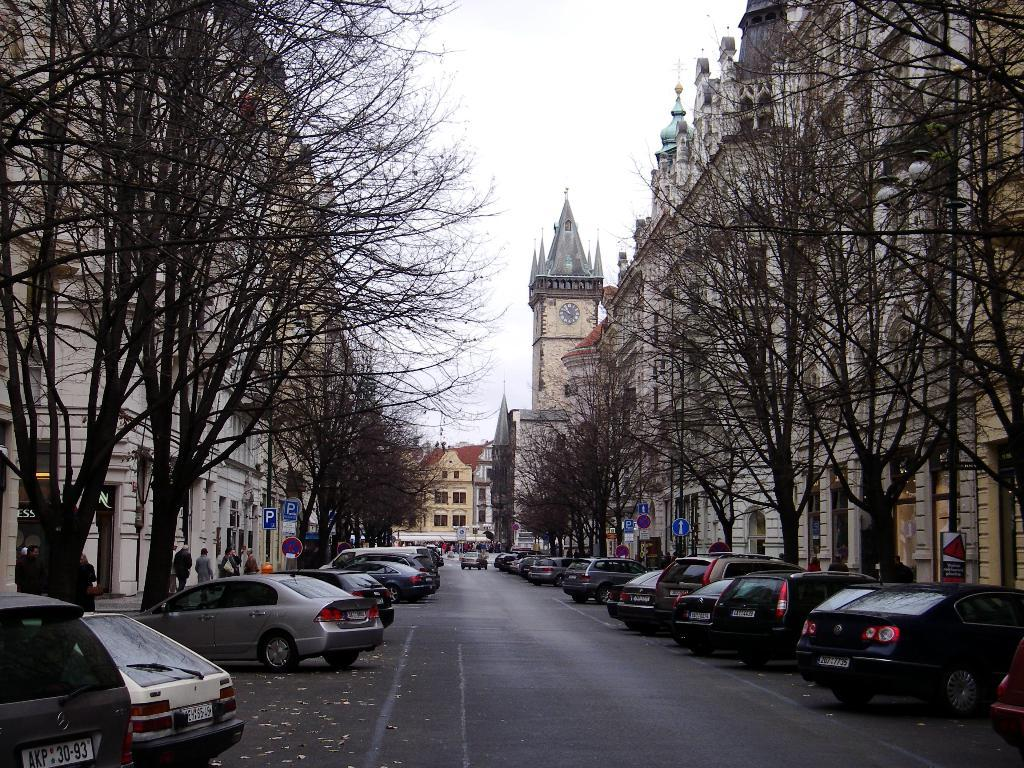What is the main feature of the image? There is a road in the image. What else can be seen on the road? There are vehicles in the image. What type of natural elements are present in the image? There are trees in the image. What type of man-made structures are present in the image? There are buildings in the image. What type of information might be conveyed by the sign boards in the image? There are sign boards in the image that might provide directions or information. Who or what else is present in the image? There are people in the image. Where is the playground located in the image? There is no playground present in the image. What type of ray can be seen interacting with the people in the image? There is no ray present in the image; it is a scene of a road, vehicles, trees, buildings, sign boards, and people. 